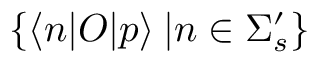Convert formula to latex. <formula><loc_0><loc_0><loc_500><loc_500>\{ \langle n | O | p \rangle \, | n \in \Sigma _ { s } ^ { \prime } \}</formula> 